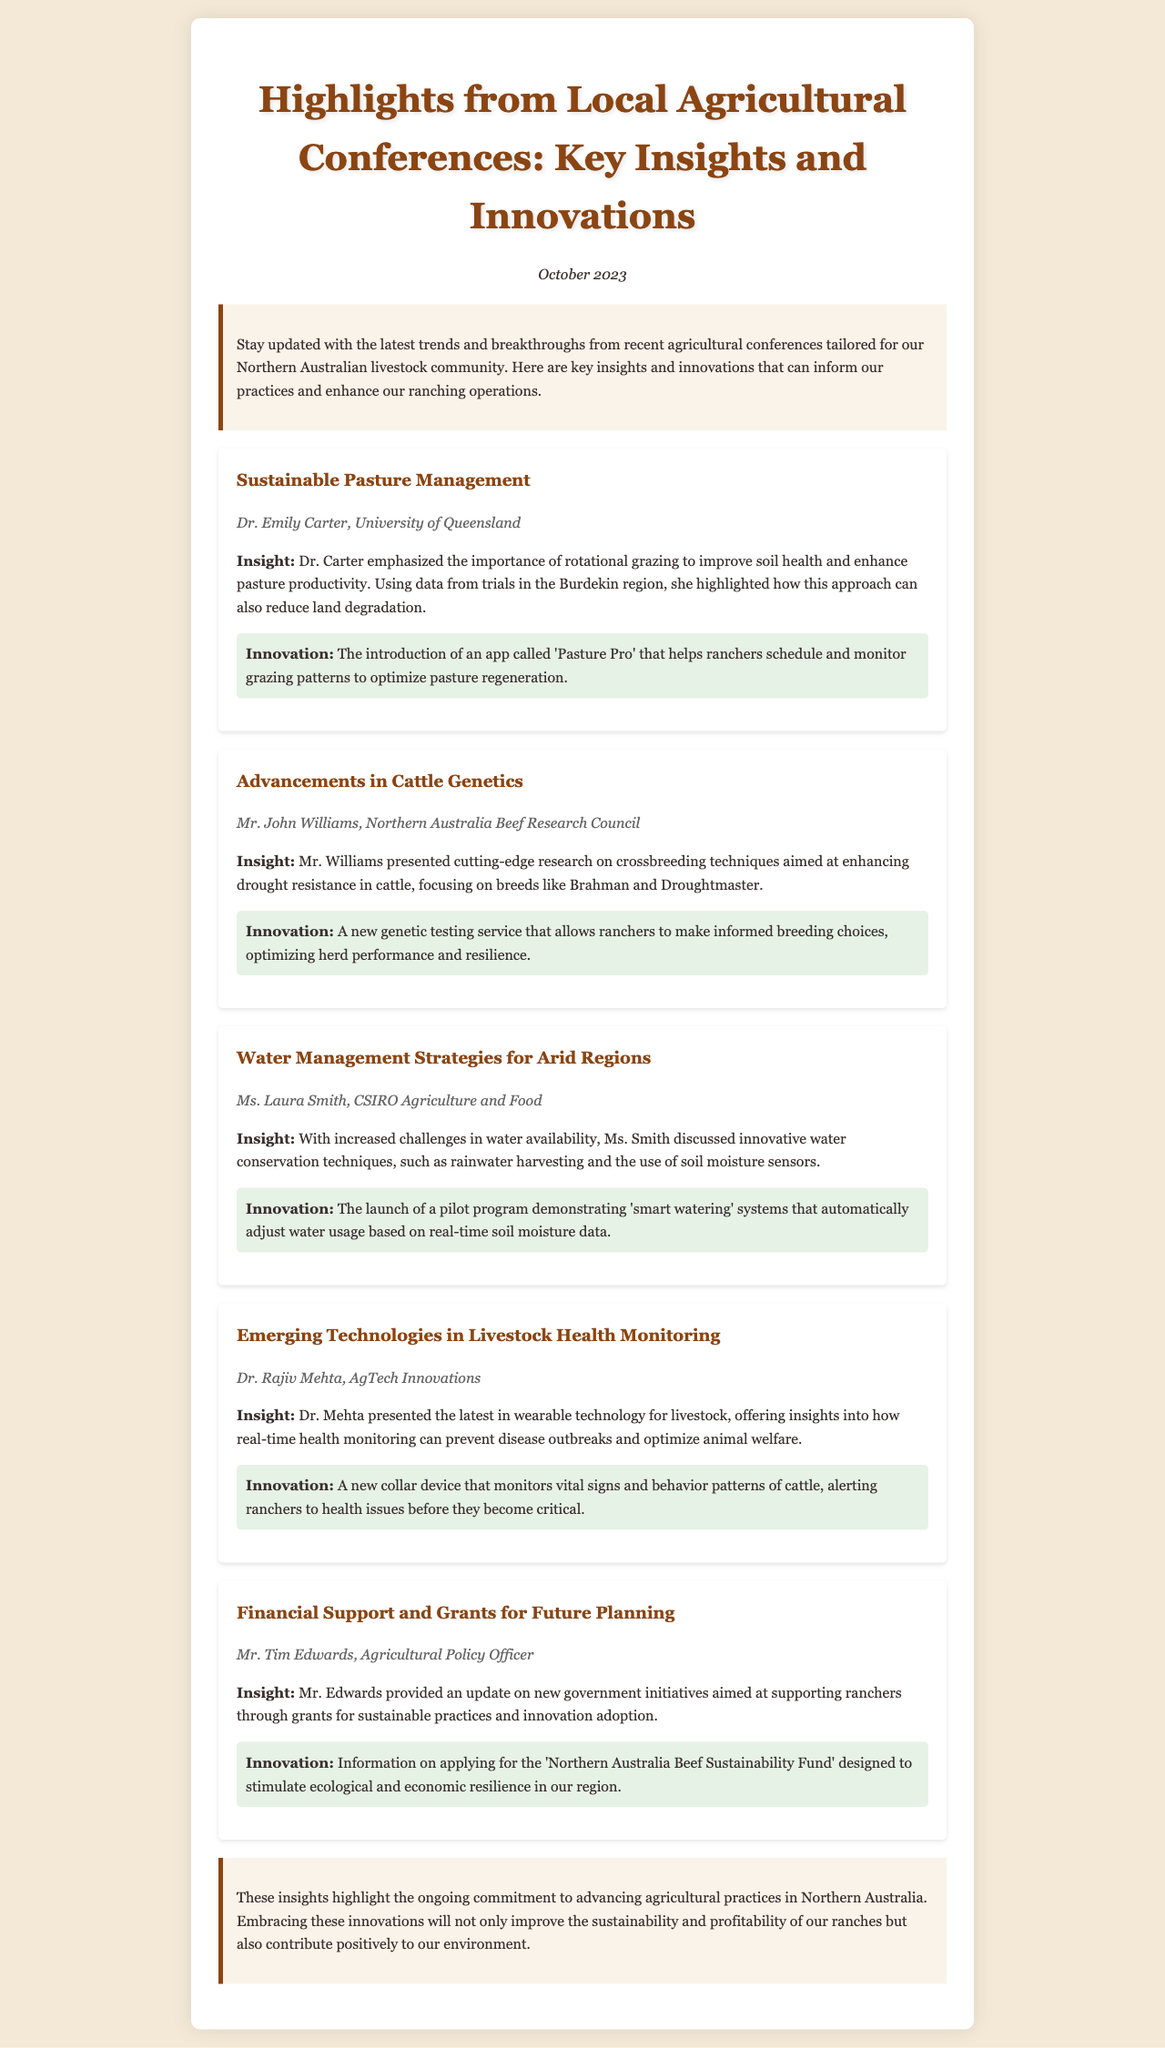What is the title of the newsletter? The title of the newsletter is highlighted prominently at the top, summarizing the focus of the content.
Answer: Highlights from Local Agricultural Conferences: Key Insights and Innovations Who presented on Sustainable Pasture Management? The speaker for Sustainable Pasture Management is noted, adding credibility to the insights shared.
Answer: Dr. Emily Carter What is the name of the app introduced for pasture management? The app designed to assist ranchers with grazing patterns is specified in the insights.
Answer: Pasture Pro Which cattle breeds are mentioned for enhancing drought resistance? The breeds discussed are directly related to the advancements in cattle genetics and suitable for our climate.
Answer: Brahman and Droughtmaster What innovative water conservation technique was discussed? An innovative approach for managing water resources is specified to address challenges in arid regions.
Answer: Rainwater harvesting Who provided information about financial support and grants? The person who discussed government initiatives for ranchers is named, indicating their role in policy.
Answer: Mr. Tim Edwards What new collar device was presented for livestock health monitoring? The device designed for monitoring vital signs is mentioned as a significant innovation for ranchers.
Answer: Collar device What is the purpose of the 'Northern Australia Beef Sustainability Fund'? The fund's objective is summarized, reflecting its goal as mentioned in the insights.
Answer: Stimulate ecological and economic resilience What date was the newsletter published? The date reflects the timing of the conference highlights and the relevance of the information.
Answer: October 2023 